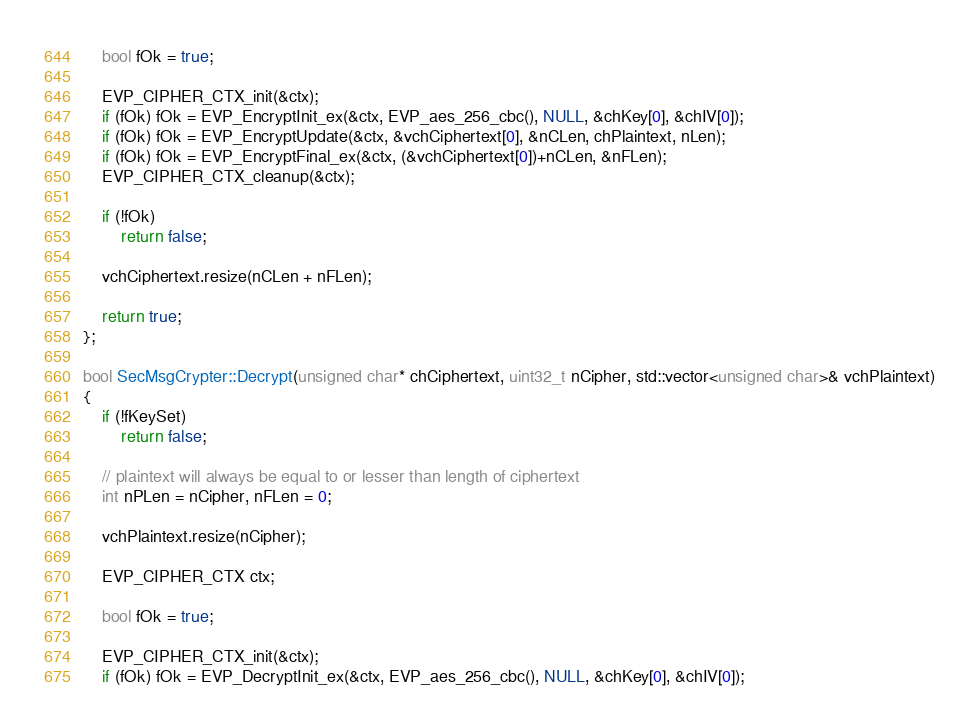Convert code to text. <code><loc_0><loc_0><loc_500><loc_500><_C++_>
    bool fOk = true;

    EVP_CIPHER_CTX_init(&ctx);
    if (fOk) fOk = EVP_EncryptInit_ex(&ctx, EVP_aes_256_cbc(), NULL, &chKey[0], &chIV[0]);
    if (fOk) fOk = EVP_EncryptUpdate(&ctx, &vchCiphertext[0], &nCLen, chPlaintext, nLen);
    if (fOk) fOk = EVP_EncryptFinal_ex(&ctx, (&vchCiphertext[0])+nCLen, &nFLen);
    EVP_CIPHER_CTX_cleanup(&ctx);

    if (!fOk)
        return false;

    vchCiphertext.resize(nCLen + nFLen);
    
    return true;
};

bool SecMsgCrypter::Decrypt(unsigned char* chCiphertext, uint32_t nCipher, std::vector<unsigned char>& vchPlaintext)
{
    if (!fKeySet)
        return false;
    
    // plaintext will always be equal to or lesser than length of ciphertext
    int nPLen = nCipher, nFLen = 0;
    
    vchPlaintext.resize(nCipher);

    EVP_CIPHER_CTX ctx;

    bool fOk = true;

    EVP_CIPHER_CTX_init(&ctx);
    if (fOk) fOk = EVP_DecryptInit_ex(&ctx, EVP_aes_256_cbc(), NULL, &chKey[0], &chIV[0]);</code> 